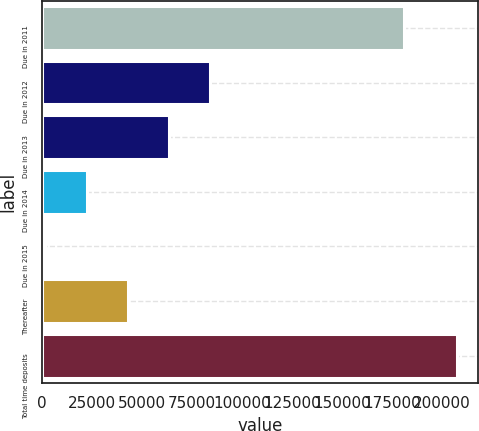Convert chart. <chart><loc_0><loc_0><loc_500><loc_500><bar_chart><fcel>Due in 2011<fcel>Due in 2012<fcel>Due in 2013<fcel>Due in 2014<fcel>Due in 2015<fcel>Thereafter<fcel>Total time deposits<nl><fcel>181280<fcel>84179.6<fcel>63583.2<fcel>22390.4<fcel>1794<fcel>42986.8<fcel>207758<nl></chart> 